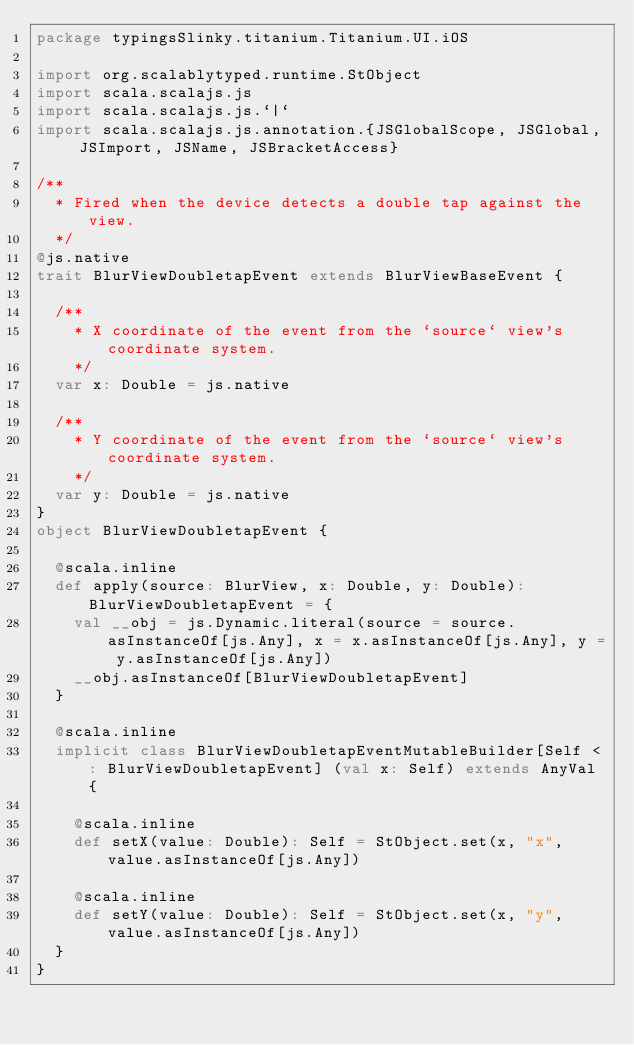Convert code to text. <code><loc_0><loc_0><loc_500><loc_500><_Scala_>package typingsSlinky.titanium.Titanium.UI.iOS

import org.scalablytyped.runtime.StObject
import scala.scalajs.js
import scala.scalajs.js.`|`
import scala.scalajs.js.annotation.{JSGlobalScope, JSGlobal, JSImport, JSName, JSBracketAccess}

/**
  * Fired when the device detects a double tap against the view.
  */
@js.native
trait BlurViewDoubletapEvent extends BlurViewBaseEvent {
  
  /**
    * X coordinate of the event from the `source` view's coordinate system.
    */
  var x: Double = js.native
  
  /**
    * Y coordinate of the event from the `source` view's coordinate system.
    */
  var y: Double = js.native
}
object BlurViewDoubletapEvent {
  
  @scala.inline
  def apply(source: BlurView, x: Double, y: Double): BlurViewDoubletapEvent = {
    val __obj = js.Dynamic.literal(source = source.asInstanceOf[js.Any], x = x.asInstanceOf[js.Any], y = y.asInstanceOf[js.Any])
    __obj.asInstanceOf[BlurViewDoubletapEvent]
  }
  
  @scala.inline
  implicit class BlurViewDoubletapEventMutableBuilder[Self <: BlurViewDoubletapEvent] (val x: Self) extends AnyVal {
    
    @scala.inline
    def setX(value: Double): Self = StObject.set(x, "x", value.asInstanceOf[js.Any])
    
    @scala.inline
    def setY(value: Double): Self = StObject.set(x, "y", value.asInstanceOf[js.Any])
  }
}
</code> 